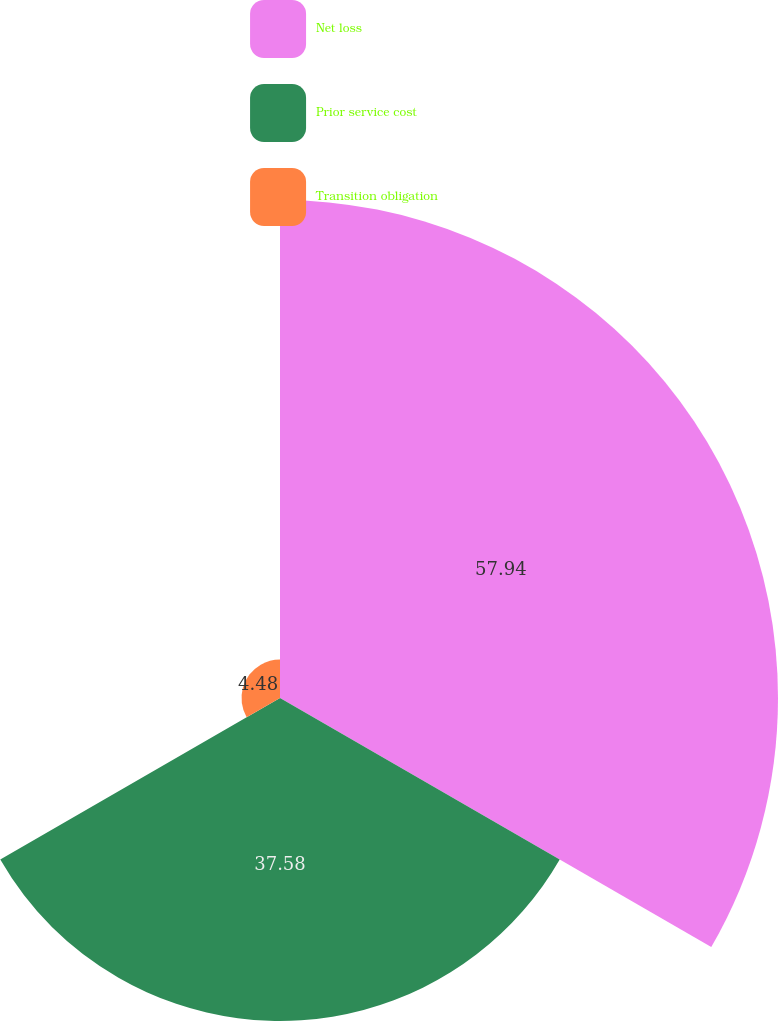Convert chart. <chart><loc_0><loc_0><loc_500><loc_500><pie_chart><fcel>Net loss<fcel>Prior service cost<fcel>Transition obligation<nl><fcel>57.94%<fcel>37.58%<fcel>4.48%<nl></chart> 